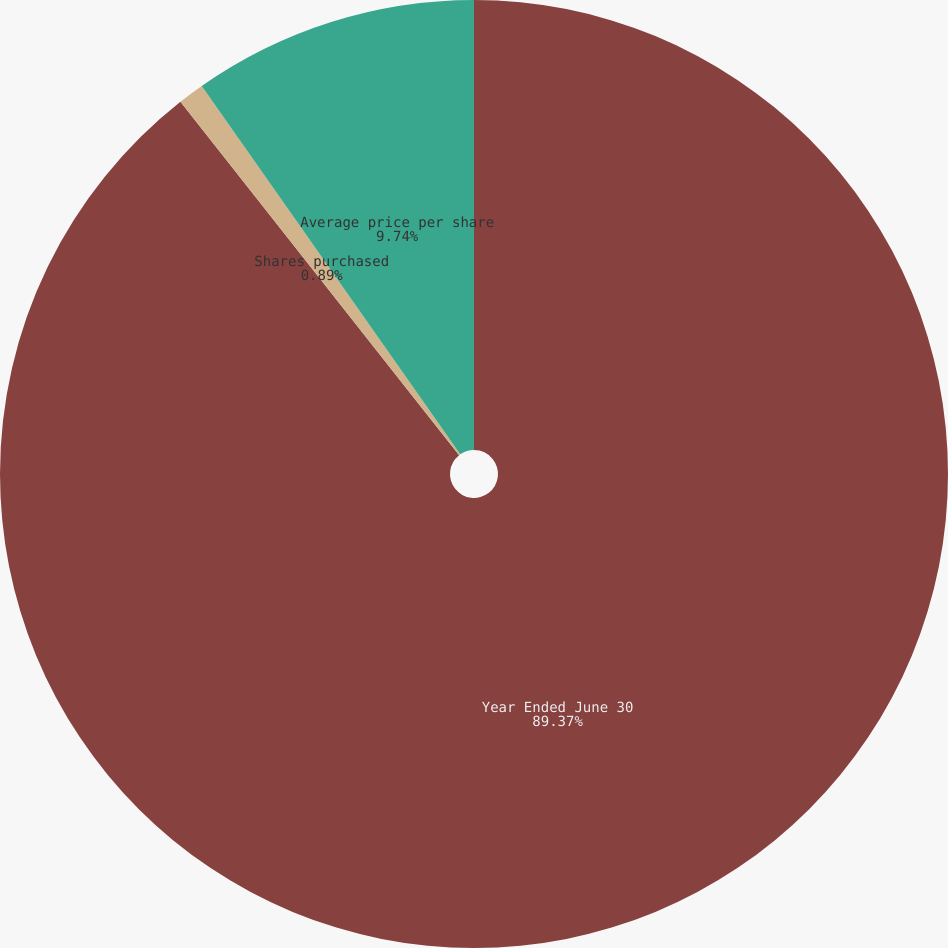Convert chart. <chart><loc_0><loc_0><loc_500><loc_500><pie_chart><fcel>Year Ended June 30<fcel>Shares purchased<fcel>Average price per share<nl><fcel>89.37%<fcel>0.89%<fcel>9.74%<nl></chart> 